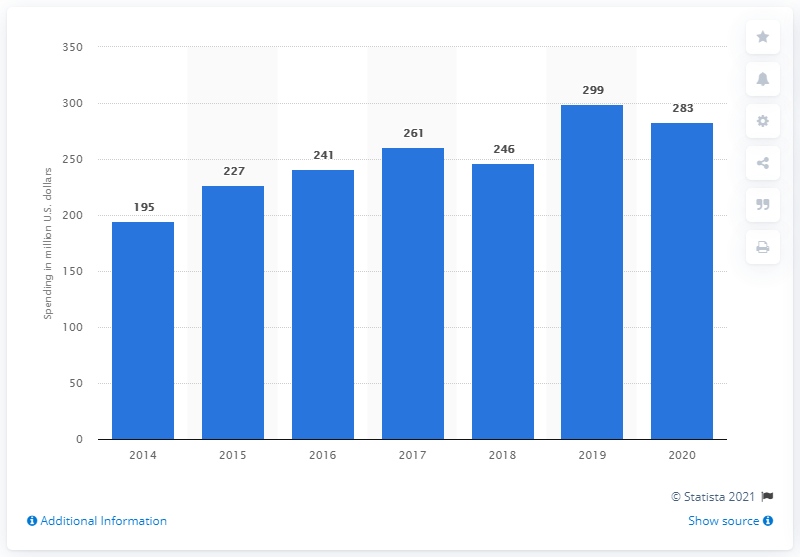Outline some significant characteristics in this image. Nordstrom invested approximately 283 million USD in advertising worldwide in 2020. 